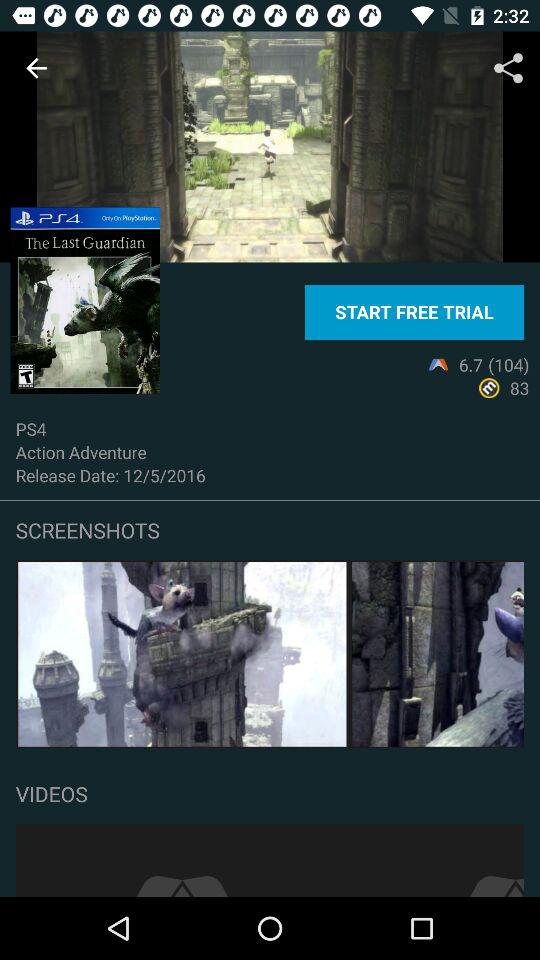What is the platform? The platform is PS4. 